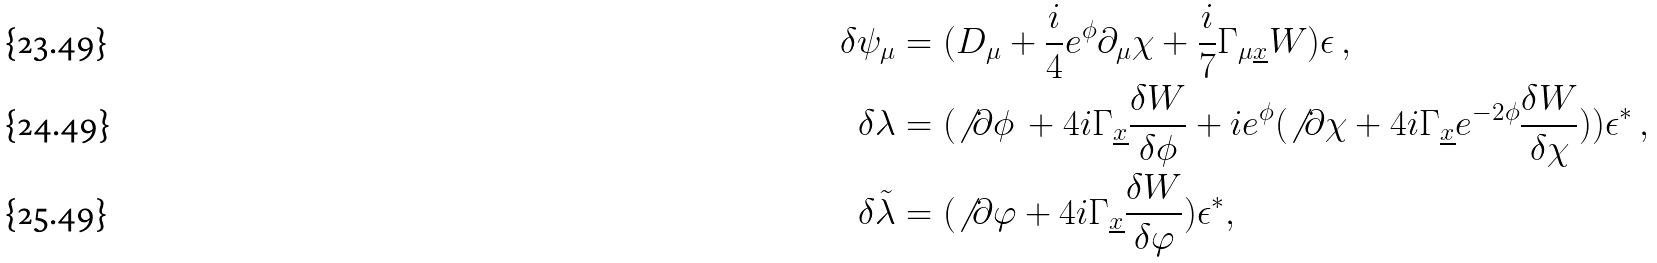Convert formula to latex. <formula><loc_0><loc_0><loc_500><loc_500>\delta \psi _ { \mu } & = ( D _ { \mu } + \frac { i } { 4 } e ^ { \phi } \partial _ { \mu } \chi + \frac { i } { 7 } \Gamma _ { \mu \underline { x } } W ) \epsilon \, , \\ \delta \lambda & = ( \not \, \partial \phi \, + 4 i \Gamma _ { \underline { x } } \frac { \delta W } { \delta \phi } + i e ^ { \phi } ( \not \, \partial \chi + 4 i \Gamma _ { \underline { x } } e ^ { - 2 \phi } \frac { \delta W } { \delta \chi } ) ) \epsilon ^ { * } \, , \\ \delta \tilde { \lambda } & = ( \not \, \partial \varphi + 4 i \Gamma _ { \underline { x } } \frac { \delta W } { \delta \varphi } ) \epsilon ^ { * } ,</formula> 